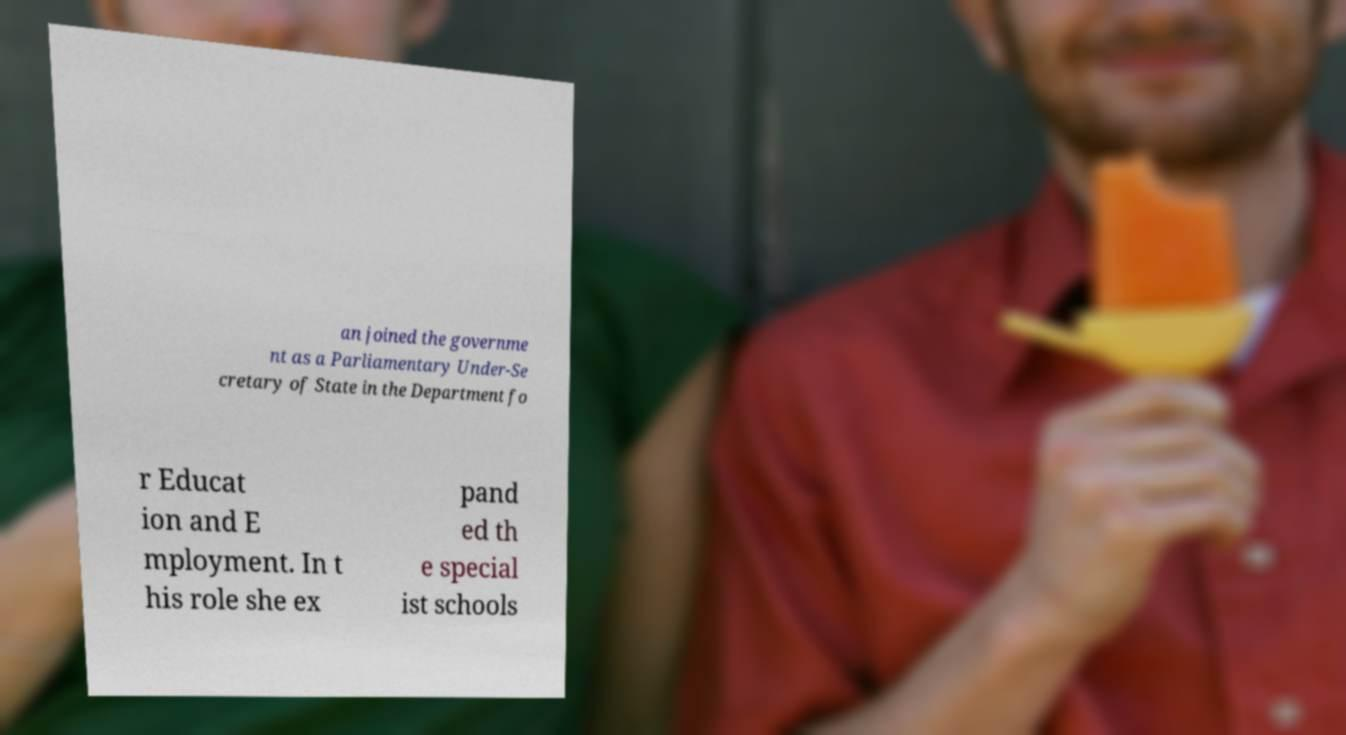Please read and relay the text visible in this image. What does it say? an joined the governme nt as a Parliamentary Under-Se cretary of State in the Department fo r Educat ion and E mployment. In t his role she ex pand ed th e special ist schools 